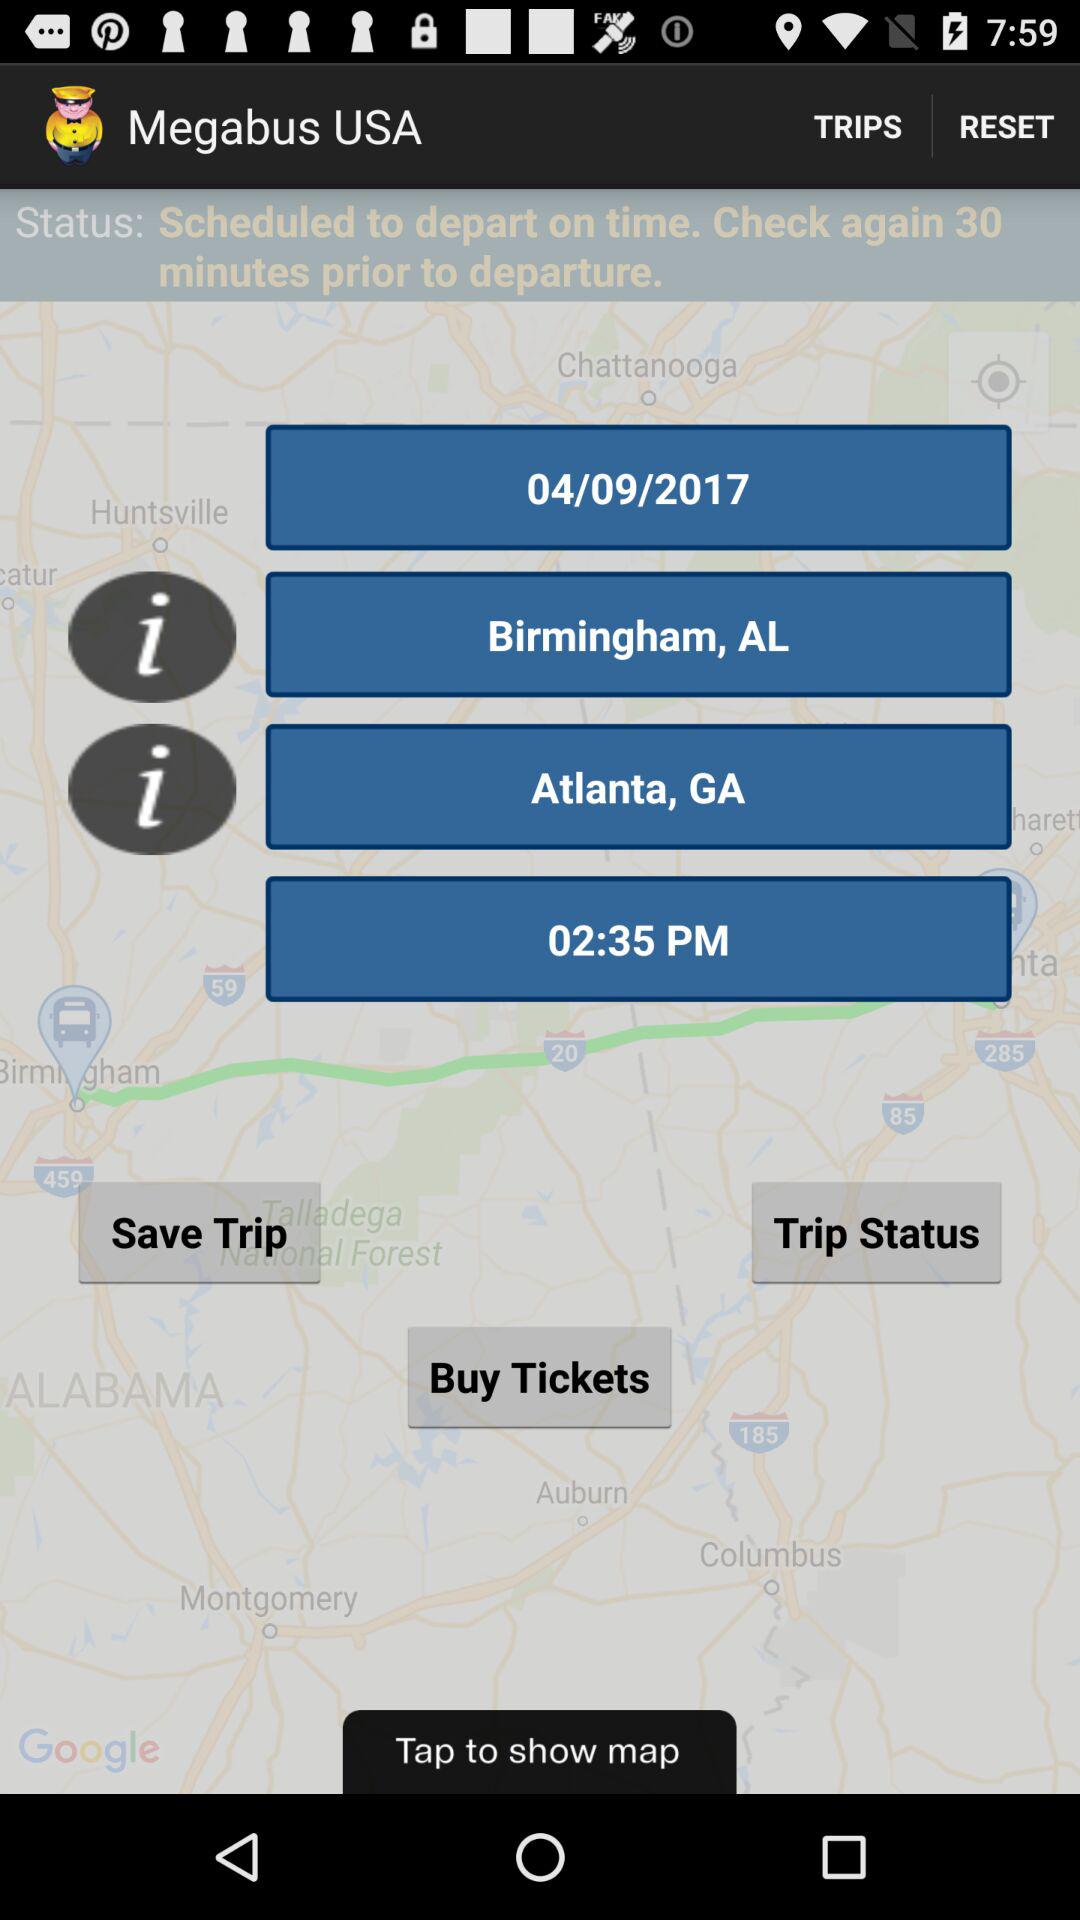How many hours and minutes until the departure time?
Answer the question using a single word or phrase. 2 hours and 35 minutes 